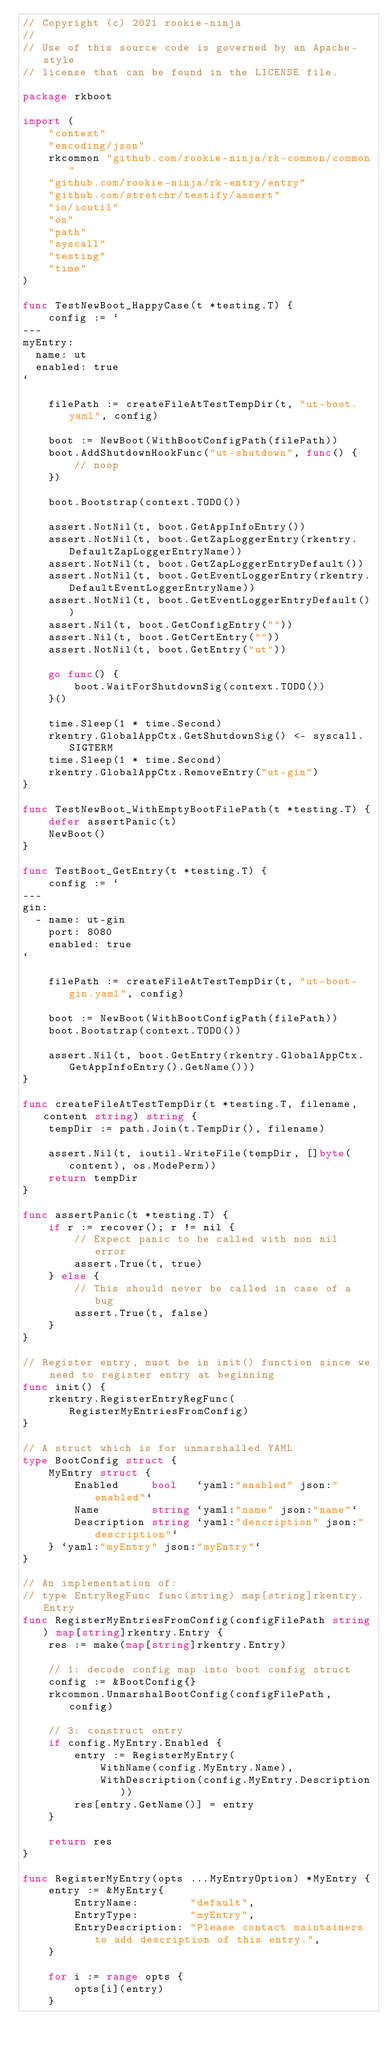<code> <loc_0><loc_0><loc_500><loc_500><_Go_>// Copyright (c) 2021 rookie-ninja
//
// Use of this source code is governed by an Apache-style
// license that can be found in the LICENSE file.

package rkboot

import (
	"context"
	"encoding/json"
	rkcommon "github.com/rookie-ninja/rk-common/common"
	"github.com/rookie-ninja/rk-entry/entry"
	"github.com/stretchr/testify/assert"
	"io/ioutil"
	"os"
	"path"
	"syscall"
	"testing"
	"time"
)

func TestNewBoot_HappyCase(t *testing.T) {
	config := `
---
myEntry:
  name: ut
  enabled: true
`

	filePath := createFileAtTestTempDir(t, "ut-boot.yaml", config)

	boot := NewBoot(WithBootConfigPath(filePath))
	boot.AddShutdownHookFunc("ut-shutdown", func() {
		// noop
	})

	boot.Bootstrap(context.TODO())

	assert.NotNil(t, boot.GetAppInfoEntry())
	assert.NotNil(t, boot.GetZapLoggerEntry(rkentry.DefaultZapLoggerEntryName))
	assert.NotNil(t, boot.GetZapLoggerEntryDefault())
	assert.NotNil(t, boot.GetEventLoggerEntry(rkentry.DefaultEventLoggerEntryName))
	assert.NotNil(t, boot.GetEventLoggerEntryDefault())
	assert.Nil(t, boot.GetConfigEntry(""))
	assert.Nil(t, boot.GetCertEntry(""))
	assert.NotNil(t, boot.GetEntry("ut"))

	go func() {
		boot.WaitForShutdownSig(context.TODO())
	}()

	time.Sleep(1 * time.Second)
	rkentry.GlobalAppCtx.GetShutdownSig() <- syscall.SIGTERM
	time.Sleep(1 * time.Second)
	rkentry.GlobalAppCtx.RemoveEntry("ut-gin")
}

func TestNewBoot_WithEmptyBootFilePath(t *testing.T) {
	defer assertPanic(t)
	NewBoot()
}

func TestBoot_GetEntry(t *testing.T) {
	config := `
---
gin:
  - name: ut-gin
    port: 8080
    enabled: true
`

	filePath := createFileAtTestTempDir(t, "ut-boot-gin.yaml", config)

	boot := NewBoot(WithBootConfigPath(filePath))
	boot.Bootstrap(context.TODO())

	assert.Nil(t, boot.GetEntry(rkentry.GlobalAppCtx.GetAppInfoEntry().GetName()))
}

func createFileAtTestTempDir(t *testing.T, filename, content string) string {
	tempDir := path.Join(t.TempDir(), filename)

	assert.Nil(t, ioutil.WriteFile(tempDir, []byte(content), os.ModePerm))
	return tempDir
}

func assertPanic(t *testing.T) {
	if r := recover(); r != nil {
		// Expect panic to be called with non nil error
		assert.True(t, true)
	} else {
		// This should never be called in case of a bug
		assert.True(t, false)
	}
}

// Register entry, must be in init() function since we need to register entry at beginning
func init() {
	rkentry.RegisterEntryRegFunc(RegisterMyEntriesFromConfig)
}

// A struct which is for unmarshalled YAML
type BootConfig struct {
	MyEntry struct {
		Enabled     bool   `yaml:"enabled" json:"enabled"`
		Name        string `yaml:"name" json:"name"`
		Description string `yaml:"description" json:"description"`
	} `yaml:"myEntry" json:"myEntry"`
}

// An implementation of:
// type EntryRegFunc func(string) map[string]rkentry.Entry
func RegisterMyEntriesFromConfig(configFilePath string) map[string]rkentry.Entry {
	res := make(map[string]rkentry.Entry)

	// 1: decode config map into boot config struct
	config := &BootConfig{}
	rkcommon.UnmarshalBootConfig(configFilePath, config)

	// 3: construct entry
	if config.MyEntry.Enabled {
		entry := RegisterMyEntry(
			WithName(config.MyEntry.Name),
			WithDescription(config.MyEntry.Description))
		res[entry.GetName()] = entry
	}

	return res
}

func RegisterMyEntry(opts ...MyEntryOption) *MyEntry {
	entry := &MyEntry{
		EntryName:        "default",
		EntryType:        "myEntry",
		EntryDescription: "Please contact maintainers to add description of this entry.",
	}

	for i := range opts {
		opts[i](entry)
	}
</code> 